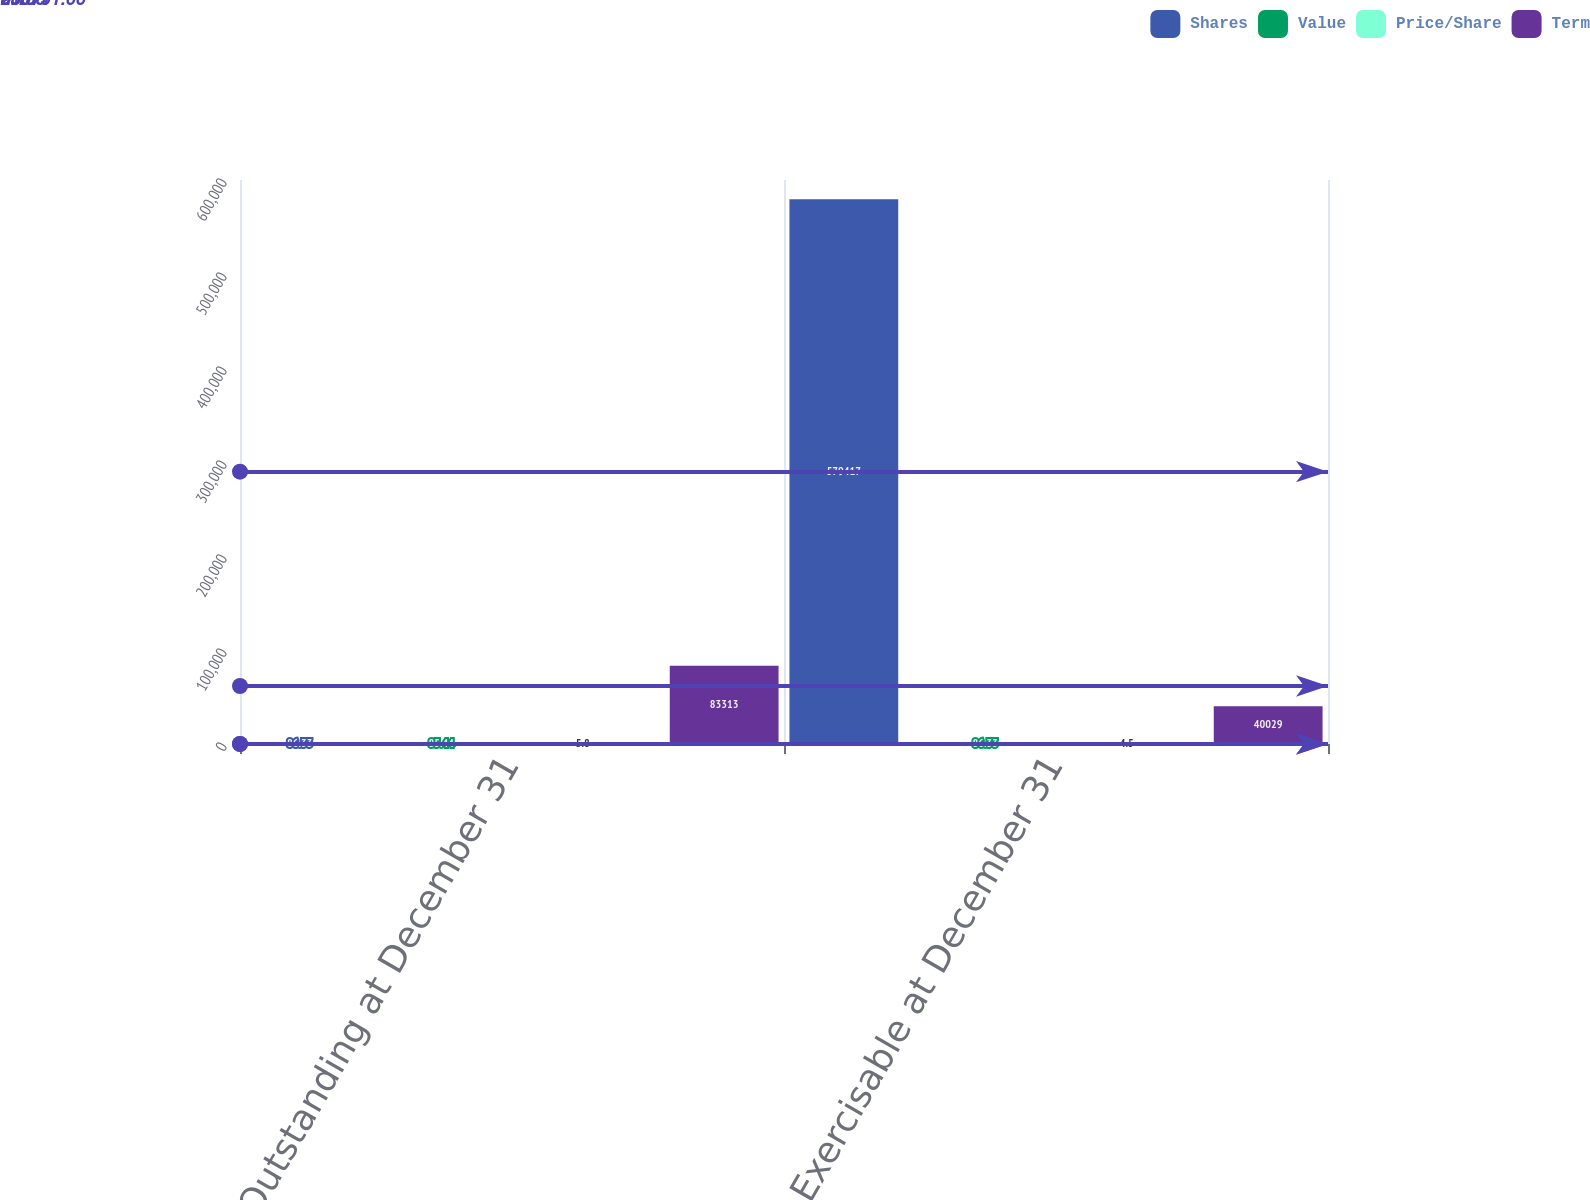Convert chart. <chart><loc_0><loc_0><loc_500><loc_500><stacked_bar_chart><ecel><fcel>Outstanding at December 31<fcel>Exercisable at December 31<nl><fcel>Shares<fcel>86.33<fcel>579417<nl><fcel>Value<fcel>85.44<fcel>86.33<nl><fcel>Price/Share<fcel>5.8<fcel>4.5<nl><fcel>Term<fcel>83313<fcel>40029<nl></chart> 